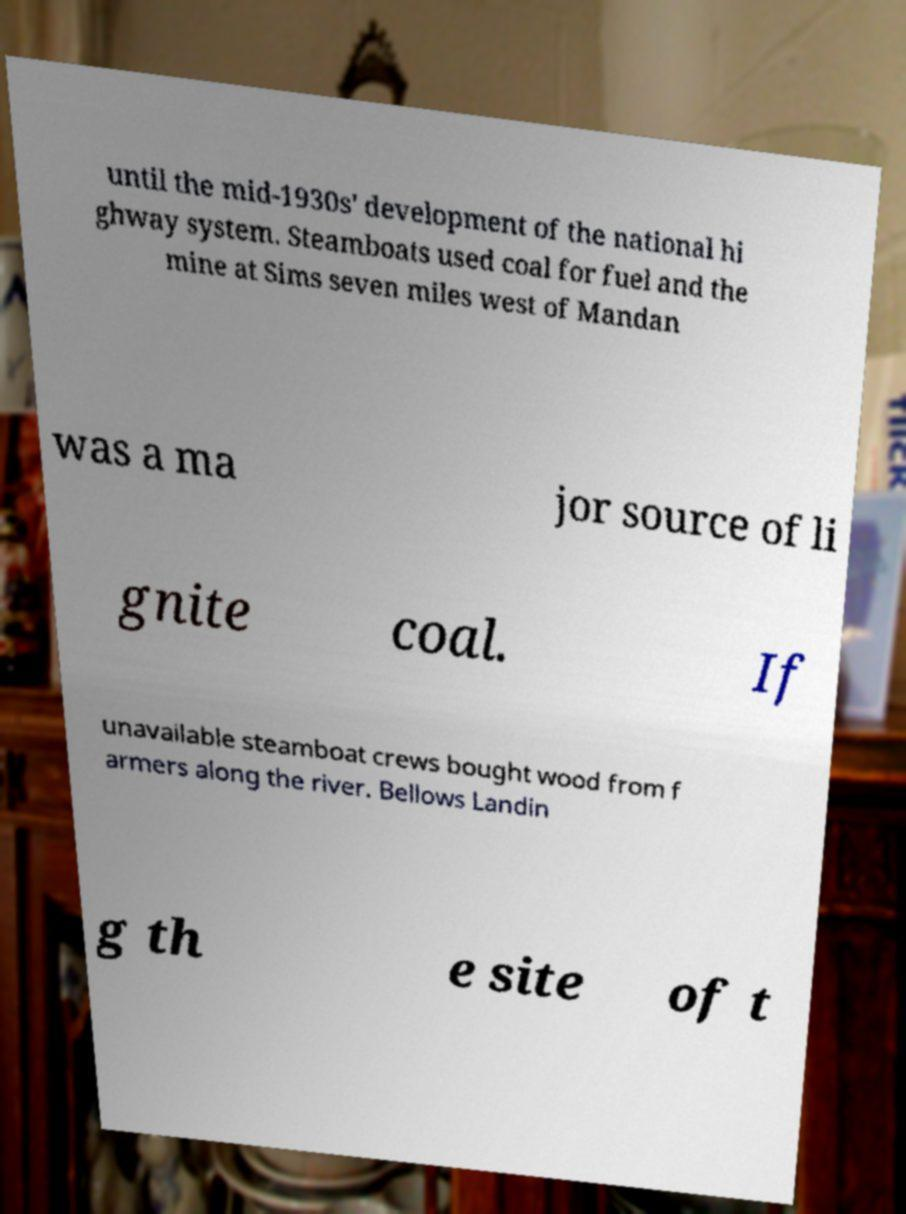Could you assist in decoding the text presented in this image and type it out clearly? until the mid-1930s' development of the national hi ghway system. Steamboats used coal for fuel and the mine at Sims seven miles west of Mandan was a ma jor source of li gnite coal. If unavailable steamboat crews bought wood from f armers along the river. Bellows Landin g th e site of t 